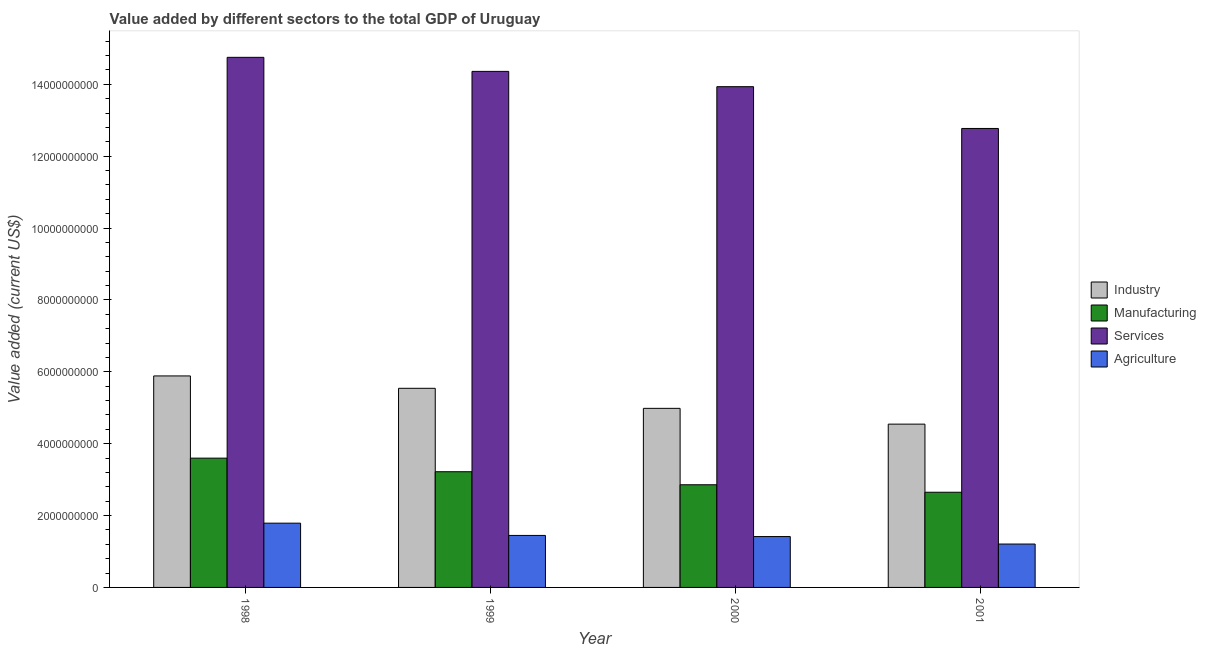How many different coloured bars are there?
Your answer should be compact. 4. How many groups of bars are there?
Your response must be concise. 4. How many bars are there on the 2nd tick from the left?
Your response must be concise. 4. What is the value added by manufacturing sector in 1999?
Provide a succinct answer. 3.22e+09. Across all years, what is the maximum value added by services sector?
Make the answer very short. 1.48e+1. Across all years, what is the minimum value added by industrial sector?
Offer a terse response. 4.54e+09. What is the total value added by services sector in the graph?
Provide a short and direct response. 5.58e+1. What is the difference between the value added by manufacturing sector in 1998 and that in 2001?
Your response must be concise. 9.49e+08. What is the difference between the value added by manufacturing sector in 2001 and the value added by services sector in 1999?
Give a very brief answer. -5.71e+08. What is the average value added by agricultural sector per year?
Your response must be concise. 1.46e+09. What is the ratio of the value added by agricultural sector in 1999 to that in 2000?
Make the answer very short. 1.02. Is the value added by agricultural sector in 1998 less than that in 2000?
Your response must be concise. No. Is the difference between the value added by manufacturing sector in 1998 and 2000 greater than the difference between the value added by industrial sector in 1998 and 2000?
Provide a short and direct response. No. What is the difference between the highest and the second highest value added by services sector?
Your answer should be compact. 3.91e+08. What is the difference between the highest and the lowest value added by manufacturing sector?
Provide a succinct answer. 9.49e+08. What does the 2nd bar from the left in 1998 represents?
Give a very brief answer. Manufacturing. What does the 4th bar from the right in 2001 represents?
Offer a very short reply. Industry. How many bars are there?
Your answer should be compact. 16. Are all the bars in the graph horizontal?
Keep it short and to the point. No. How many years are there in the graph?
Provide a succinct answer. 4. What is the difference between two consecutive major ticks on the Y-axis?
Ensure brevity in your answer.  2.00e+09. What is the title of the graph?
Your answer should be compact. Value added by different sectors to the total GDP of Uruguay. What is the label or title of the Y-axis?
Provide a succinct answer. Value added (current US$). What is the Value added (current US$) in Industry in 1998?
Offer a very short reply. 5.89e+09. What is the Value added (current US$) in Manufacturing in 1998?
Provide a short and direct response. 3.60e+09. What is the Value added (current US$) of Services in 1998?
Ensure brevity in your answer.  1.48e+1. What is the Value added (current US$) in Agriculture in 1998?
Provide a short and direct response. 1.79e+09. What is the Value added (current US$) of Industry in 1999?
Offer a terse response. 5.54e+09. What is the Value added (current US$) of Manufacturing in 1999?
Provide a succinct answer. 3.22e+09. What is the Value added (current US$) in Services in 1999?
Provide a short and direct response. 1.44e+1. What is the Value added (current US$) of Agriculture in 1999?
Offer a very short reply. 1.45e+09. What is the Value added (current US$) in Industry in 2000?
Your answer should be compact. 4.98e+09. What is the Value added (current US$) in Manufacturing in 2000?
Provide a succinct answer. 2.86e+09. What is the Value added (current US$) of Services in 2000?
Keep it short and to the point. 1.39e+1. What is the Value added (current US$) in Agriculture in 2000?
Offer a very short reply. 1.42e+09. What is the Value added (current US$) in Industry in 2001?
Give a very brief answer. 4.54e+09. What is the Value added (current US$) in Manufacturing in 2001?
Ensure brevity in your answer.  2.65e+09. What is the Value added (current US$) of Services in 2001?
Provide a succinct answer. 1.28e+1. What is the Value added (current US$) in Agriculture in 2001?
Your response must be concise. 1.21e+09. Across all years, what is the maximum Value added (current US$) of Industry?
Give a very brief answer. 5.89e+09. Across all years, what is the maximum Value added (current US$) in Manufacturing?
Ensure brevity in your answer.  3.60e+09. Across all years, what is the maximum Value added (current US$) of Services?
Offer a very short reply. 1.48e+1. Across all years, what is the maximum Value added (current US$) of Agriculture?
Your answer should be compact. 1.79e+09. Across all years, what is the minimum Value added (current US$) in Industry?
Give a very brief answer. 4.54e+09. Across all years, what is the minimum Value added (current US$) of Manufacturing?
Your answer should be compact. 2.65e+09. Across all years, what is the minimum Value added (current US$) in Services?
Offer a very short reply. 1.28e+1. Across all years, what is the minimum Value added (current US$) in Agriculture?
Provide a short and direct response. 1.21e+09. What is the total Value added (current US$) in Industry in the graph?
Give a very brief answer. 2.10e+1. What is the total Value added (current US$) in Manufacturing in the graph?
Ensure brevity in your answer.  1.23e+1. What is the total Value added (current US$) in Services in the graph?
Make the answer very short. 5.58e+1. What is the total Value added (current US$) in Agriculture in the graph?
Ensure brevity in your answer.  5.86e+09. What is the difference between the Value added (current US$) of Industry in 1998 and that in 1999?
Keep it short and to the point. 3.45e+08. What is the difference between the Value added (current US$) in Manufacturing in 1998 and that in 1999?
Your answer should be compact. 3.78e+08. What is the difference between the Value added (current US$) in Services in 1998 and that in 1999?
Offer a terse response. 3.91e+08. What is the difference between the Value added (current US$) of Agriculture in 1998 and that in 1999?
Your answer should be very brief. 3.41e+08. What is the difference between the Value added (current US$) in Industry in 1998 and that in 2000?
Make the answer very short. 9.02e+08. What is the difference between the Value added (current US$) of Manufacturing in 1998 and that in 2000?
Your answer should be very brief. 7.40e+08. What is the difference between the Value added (current US$) in Services in 1998 and that in 2000?
Provide a short and direct response. 8.17e+08. What is the difference between the Value added (current US$) in Agriculture in 1998 and that in 2000?
Offer a terse response. 3.73e+08. What is the difference between the Value added (current US$) in Industry in 1998 and that in 2001?
Your answer should be very brief. 1.34e+09. What is the difference between the Value added (current US$) of Manufacturing in 1998 and that in 2001?
Provide a short and direct response. 9.49e+08. What is the difference between the Value added (current US$) in Services in 1998 and that in 2001?
Offer a terse response. 1.98e+09. What is the difference between the Value added (current US$) of Agriculture in 1998 and that in 2001?
Give a very brief answer. 5.81e+08. What is the difference between the Value added (current US$) in Industry in 1999 and that in 2000?
Offer a very short reply. 5.58e+08. What is the difference between the Value added (current US$) in Manufacturing in 1999 and that in 2000?
Your answer should be compact. 3.63e+08. What is the difference between the Value added (current US$) in Services in 1999 and that in 2000?
Provide a succinct answer. 4.26e+08. What is the difference between the Value added (current US$) of Agriculture in 1999 and that in 2000?
Offer a very short reply. 3.12e+07. What is the difference between the Value added (current US$) of Industry in 1999 and that in 2001?
Give a very brief answer. 9.97e+08. What is the difference between the Value added (current US$) in Manufacturing in 1999 and that in 2001?
Keep it short and to the point. 5.71e+08. What is the difference between the Value added (current US$) of Services in 1999 and that in 2001?
Provide a succinct answer. 1.59e+09. What is the difference between the Value added (current US$) of Agriculture in 1999 and that in 2001?
Keep it short and to the point. 2.40e+08. What is the difference between the Value added (current US$) of Industry in 2000 and that in 2001?
Ensure brevity in your answer.  4.39e+08. What is the difference between the Value added (current US$) in Manufacturing in 2000 and that in 2001?
Make the answer very short. 2.08e+08. What is the difference between the Value added (current US$) of Services in 2000 and that in 2001?
Offer a very short reply. 1.16e+09. What is the difference between the Value added (current US$) of Agriculture in 2000 and that in 2001?
Offer a terse response. 2.08e+08. What is the difference between the Value added (current US$) in Industry in 1998 and the Value added (current US$) in Manufacturing in 1999?
Give a very brief answer. 2.67e+09. What is the difference between the Value added (current US$) of Industry in 1998 and the Value added (current US$) of Services in 1999?
Provide a short and direct response. -8.48e+09. What is the difference between the Value added (current US$) of Industry in 1998 and the Value added (current US$) of Agriculture in 1999?
Give a very brief answer. 4.44e+09. What is the difference between the Value added (current US$) of Manufacturing in 1998 and the Value added (current US$) of Services in 1999?
Your response must be concise. -1.08e+1. What is the difference between the Value added (current US$) of Manufacturing in 1998 and the Value added (current US$) of Agriculture in 1999?
Provide a succinct answer. 2.15e+09. What is the difference between the Value added (current US$) in Services in 1998 and the Value added (current US$) in Agriculture in 1999?
Ensure brevity in your answer.  1.33e+1. What is the difference between the Value added (current US$) in Industry in 1998 and the Value added (current US$) in Manufacturing in 2000?
Make the answer very short. 3.03e+09. What is the difference between the Value added (current US$) of Industry in 1998 and the Value added (current US$) of Services in 2000?
Provide a short and direct response. -8.05e+09. What is the difference between the Value added (current US$) of Industry in 1998 and the Value added (current US$) of Agriculture in 2000?
Offer a very short reply. 4.47e+09. What is the difference between the Value added (current US$) of Manufacturing in 1998 and the Value added (current US$) of Services in 2000?
Your answer should be compact. -1.03e+1. What is the difference between the Value added (current US$) in Manufacturing in 1998 and the Value added (current US$) in Agriculture in 2000?
Ensure brevity in your answer.  2.18e+09. What is the difference between the Value added (current US$) in Services in 1998 and the Value added (current US$) in Agriculture in 2000?
Your answer should be compact. 1.33e+1. What is the difference between the Value added (current US$) of Industry in 1998 and the Value added (current US$) of Manufacturing in 2001?
Ensure brevity in your answer.  3.24e+09. What is the difference between the Value added (current US$) of Industry in 1998 and the Value added (current US$) of Services in 2001?
Your answer should be very brief. -6.89e+09. What is the difference between the Value added (current US$) of Industry in 1998 and the Value added (current US$) of Agriculture in 2001?
Provide a succinct answer. 4.68e+09. What is the difference between the Value added (current US$) in Manufacturing in 1998 and the Value added (current US$) in Services in 2001?
Offer a terse response. -9.18e+09. What is the difference between the Value added (current US$) of Manufacturing in 1998 and the Value added (current US$) of Agriculture in 2001?
Your response must be concise. 2.39e+09. What is the difference between the Value added (current US$) of Services in 1998 and the Value added (current US$) of Agriculture in 2001?
Your answer should be very brief. 1.35e+1. What is the difference between the Value added (current US$) in Industry in 1999 and the Value added (current US$) in Manufacturing in 2000?
Give a very brief answer. 2.68e+09. What is the difference between the Value added (current US$) of Industry in 1999 and the Value added (current US$) of Services in 2000?
Ensure brevity in your answer.  -8.39e+09. What is the difference between the Value added (current US$) of Industry in 1999 and the Value added (current US$) of Agriculture in 2000?
Your answer should be compact. 4.13e+09. What is the difference between the Value added (current US$) in Manufacturing in 1999 and the Value added (current US$) in Services in 2000?
Provide a succinct answer. -1.07e+1. What is the difference between the Value added (current US$) in Manufacturing in 1999 and the Value added (current US$) in Agriculture in 2000?
Your answer should be very brief. 1.80e+09. What is the difference between the Value added (current US$) in Services in 1999 and the Value added (current US$) in Agriculture in 2000?
Offer a very short reply. 1.29e+1. What is the difference between the Value added (current US$) in Industry in 1999 and the Value added (current US$) in Manufacturing in 2001?
Offer a terse response. 2.89e+09. What is the difference between the Value added (current US$) in Industry in 1999 and the Value added (current US$) in Services in 2001?
Your answer should be very brief. -7.23e+09. What is the difference between the Value added (current US$) in Industry in 1999 and the Value added (current US$) in Agriculture in 2001?
Your response must be concise. 4.33e+09. What is the difference between the Value added (current US$) in Manufacturing in 1999 and the Value added (current US$) in Services in 2001?
Offer a very short reply. -9.55e+09. What is the difference between the Value added (current US$) of Manufacturing in 1999 and the Value added (current US$) of Agriculture in 2001?
Make the answer very short. 2.01e+09. What is the difference between the Value added (current US$) of Services in 1999 and the Value added (current US$) of Agriculture in 2001?
Your answer should be compact. 1.32e+1. What is the difference between the Value added (current US$) in Industry in 2000 and the Value added (current US$) in Manufacturing in 2001?
Your answer should be compact. 2.33e+09. What is the difference between the Value added (current US$) in Industry in 2000 and the Value added (current US$) in Services in 2001?
Your response must be concise. -7.79e+09. What is the difference between the Value added (current US$) of Industry in 2000 and the Value added (current US$) of Agriculture in 2001?
Your response must be concise. 3.78e+09. What is the difference between the Value added (current US$) in Manufacturing in 2000 and the Value added (current US$) in Services in 2001?
Ensure brevity in your answer.  -9.92e+09. What is the difference between the Value added (current US$) of Manufacturing in 2000 and the Value added (current US$) of Agriculture in 2001?
Your answer should be very brief. 1.65e+09. What is the difference between the Value added (current US$) of Services in 2000 and the Value added (current US$) of Agriculture in 2001?
Make the answer very short. 1.27e+1. What is the average Value added (current US$) in Industry per year?
Offer a terse response. 5.24e+09. What is the average Value added (current US$) in Manufacturing per year?
Give a very brief answer. 3.08e+09. What is the average Value added (current US$) of Services per year?
Your response must be concise. 1.40e+1. What is the average Value added (current US$) in Agriculture per year?
Provide a short and direct response. 1.46e+09. In the year 1998, what is the difference between the Value added (current US$) in Industry and Value added (current US$) in Manufacturing?
Give a very brief answer. 2.29e+09. In the year 1998, what is the difference between the Value added (current US$) of Industry and Value added (current US$) of Services?
Provide a short and direct response. -8.87e+09. In the year 1998, what is the difference between the Value added (current US$) of Industry and Value added (current US$) of Agriculture?
Give a very brief answer. 4.10e+09. In the year 1998, what is the difference between the Value added (current US$) of Manufacturing and Value added (current US$) of Services?
Offer a terse response. -1.12e+1. In the year 1998, what is the difference between the Value added (current US$) in Manufacturing and Value added (current US$) in Agriculture?
Keep it short and to the point. 1.81e+09. In the year 1998, what is the difference between the Value added (current US$) in Services and Value added (current US$) in Agriculture?
Offer a very short reply. 1.30e+1. In the year 1999, what is the difference between the Value added (current US$) of Industry and Value added (current US$) of Manufacturing?
Make the answer very short. 2.32e+09. In the year 1999, what is the difference between the Value added (current US$) in Industry and Value added (current US$) in Services?
Offer a very short reply. -8.82e+09. In the year 1999, what is the difference between the Value added (current US$) in Industry and Value added (current US$) in Agriculture?
Ensure brevity in your answer.  4.09e+09. In the year 1999, what is the difference between the Value added (current US$) of Manufacturing and Value added (current US$) of Services?
Give a very brief answer. -1.11e+1. In the year 1999, what is the difference between the Value added (current US$) of Manufacturing and Value added (current US$) of Agriculture?
Make the answer very short. 1.77e+09. In the year 1999, what is the difference between the Value added (current US$) in Services and Value added (current US$) in Agriculture?
Offer a very short reply. 1.29e+1. In the year 2000, what is the difference between the Value added (current US$) in Industry and Value added (current US$) in Manufacturing?
Keep it short and to the point. 2.13e+09. In the year 2000, what is the difference between the Value added (current US$) of Industry and Value added (current US$) of Services?
Ensure brevity in your answer.  -8.95e+09. In the year 2000, what is the difference between the Value added (current US$) of Industry and Value added (current US$) of Agriculture?
Provide a short and direct response. 3.57e+09. In the year 2000, what is the difference between the Value added (current US$) in Manufacturing and Value added (current US$) in Services?
Give a very brief answer. -1.11e+1. In the year 2000, what is the difference between the Value added (current US$) of Manufacturing and Value added (current US$) of Agriculture?
Offer a very short reply. 1.44e+09. In the year 2000, what is the difference between the Value added (current US$) in Services and Value added (current US$) in Agriculture?
Keep it short and to the point. 1.25e+1. In the year 2001, what is the difference between the Value added (current US$) of Industry and Value added (current US$) of Manufacturing?
Offer a terse response. 1.90e+09. In the year 2001, what is the difference between the Value added (current US$) of Industry and Value added (current US$) of Services?
Ensure brevity in your answer.  -8.23e+09. In the year 2001, what is the difference between the Value added (current US$) in Industry and Value added (current US$) in Agriculture?
Make the answer very short. 3.34e+09. In the year 2001, what is the difference between the Value added (current US$) in Manufacturing and Value added (current US$) in Services?
Your answer should be compact. -1.01e+1. In the year 2001, what is the difference between the Value added (current US$) of Manufacturing and Value added (current US$) of Agriculture?
Provide a short and direct response. 1.44e+09. In the year 2001, what is the difference between the Value added (current US$) in Services and Value added (current US$) in Agriculture?
Your answer should be compact. 1.16e+1. What is the ratio of the Value added (current US$) of Industry in 1998 to that in 1999?
Give a very brief answer. 1.06. What is the ratio of the Value added (current US$) of Manufacturing in 1998 to that in 1999?
Provide a succinct answer. 1.12. What is the ratio of the Value added (current US$) in Services in 1998 to that in 1999?
Your response must be concise. 1.03. What is the ratio of the Value added (current US$) of Agriculture in 1998 to that in 1999?
Ensure brevity in your answer.  1.24. What is the ratio of the Value added (current US$) of Industry in 1998 to that in 2000?
Your response must be concise. 1.18. What is the ratio of the Value added (current US$) of Manufacturing in 1998 to that in 2000?
Your answer should be very brief. 1.26. What is the ratio of the Value added (current US$) of Services in 1998 to that in 2000?
Your answer should be very brief. 1.06. What is the ratio of the Value added (current US$) in Agriculture in 1998 to that in 2000?
Your response must be concise. 1.26. What is the ratio of the Value added (current US$) of Industry in 1998 to that in 2001?
Keep it short and to the point. 1.3. What is the ratio of the Value added (current US$) in Manufacturing in 1998 to that in 2001?
Provide a short and direct response. 1.36. What is the ratio of the Value added (current US$) of Services in 1998 to that in 2001?
Keep it short and to the point. 1.16. What is the ratio of the Value added (current US$) of Agriculture in 1998 to that in 2001?
Ensure brevity in your answer.  1.48. What is the ratio of the Value added (current US$) in Industry in 1999 to that in 2000?
Give a very brief answer. 1.11. What is the ratio of the Value added (current US$) of Manufacturing in 1999 to that in 2000?
Your response must be concise. 1.13. What is the ratio of the Value added (current US$) of Services in 1999 to that in 2000?
Offer a terse response. 1.03. What is the ratio of the Value added (current US$) in Industry in 1999 to that in 2001?
Provide a succinct answer. 1.22. What is the ratio of the Value added (current US$) of Manufacturing in 1999 to that in 2001?
Make the answer very short. 1.22. What is the ratio of the Value added (current US$) in Services in 1999 to that in 2001?
Provide a short and direct response. 1.12. What is the ratio of the Value added (current US$) in Agriculture in 1999 to that in 2001?
Your answer should be very brief. 1.2. What is the ratio of the Value added (current US$) in Industry in 2000 to that in 2001?
Give a very brief answer. 1.1. What is the ratio of the Value added (current US$) of Manufacturing in 2000 to that in 2001?
Ensure brevity in your answer.  1.08. What is the ratio of the Value added (current US$) of Services in 2000 to that in 2001?
Offer a terse response. 1.09. What is the ratio of the Value added (current US$) in Agriculture in 2000 to that in 2001?
Keep it short and to the point. 1.17. What is the difference between the highest and the second highest Value added (current US$) of Industry?
Provide a succinct answer. 3.45e+08. What is the difference between the highest and the second highest Value added (current US$) of Manufacturing?
Offer a very short reply. 3.78e+08. What is the difference between the highest and the second highest Value added (current US$) of Services?
Give a very brief answer. 3.91e+08. What is the difference between the highest and the second highest Value added (current US$) in Agriculture?
Make the answer very short. 3.41e+08. What is the difference between the highest and the lowest Value added (current US$) in Industry?
Make the answer very short. 1.34e+09. What is the difference between the highest and the lowest Value added (current US$) in Manufacturing?
Give a very brief answer. 9.49e+08. What is the difference between the highest and the lowest Value added (current US$) of Services?
Provide a succinct answer. 1.98e+09. What is the difference between the highest and the lowest Value added (current US$) in Agriculture?
Ensure brevity in your answer.  5.81e+08. 